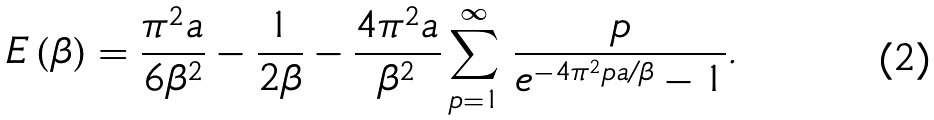Convert formula to latex. <formula><loc_0><loc_0><loc_500><loc_500>E \left ( \beta \right ) = \frac { \pi ^ { 2 } a } { 6 \beta ^ { 2 } } - \frac { 1 } { 2 \beta } - \frac { 4 \pi ^ { 2 } a } { \beta ^ { 2 } } \sum ^ { \infty } _ { p = 1 } \, \frac { p } { e ^ { - 4 \pi ^ { 2 } p a / \beta } - 1 } .</formula> 